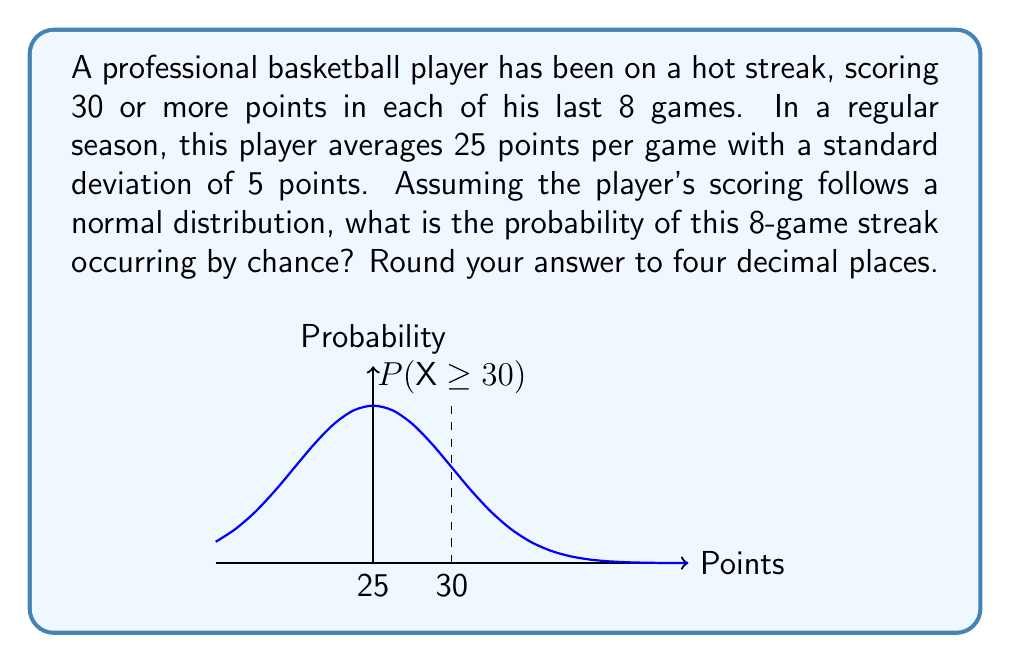Solve this math problem. To solve this problem, we'll follow these steps:

1) First, we need to calculate the z-score for 30 points:

   $z = \frac{x - \mu}{\sigma} = \frac{30 - 25}{5} = 1$

2) Now, we need to find the probability of scoring 30 or more points in a single game. This is the area to the right of z = 1 on a standard normal distribution curve.

   $P(X \geq 30) = 1 - P(X < 30) = 1 - \Phi(1) \approx 0.1587$

   Where $\Phi(1)$ is the cumulative distribution function of the standard normal distribution at z = 1.

3) The probability of this happening in 8 consecutive games is:

   $P(\text{8 game streak}) = (0.1587)^8 \approx 0.0000002563$

4) Rounding to four decimal places:

   $0.0000002563 \approx 0.0000$

This extremely low probability suggests that the player's streak is statistically significant and unlikely to occur by chance, indicating that the player's performance during this streak is likely due to factors beyond their usual play (such as improved skills, strategy, or other external factors).
Answer: 0.0000 